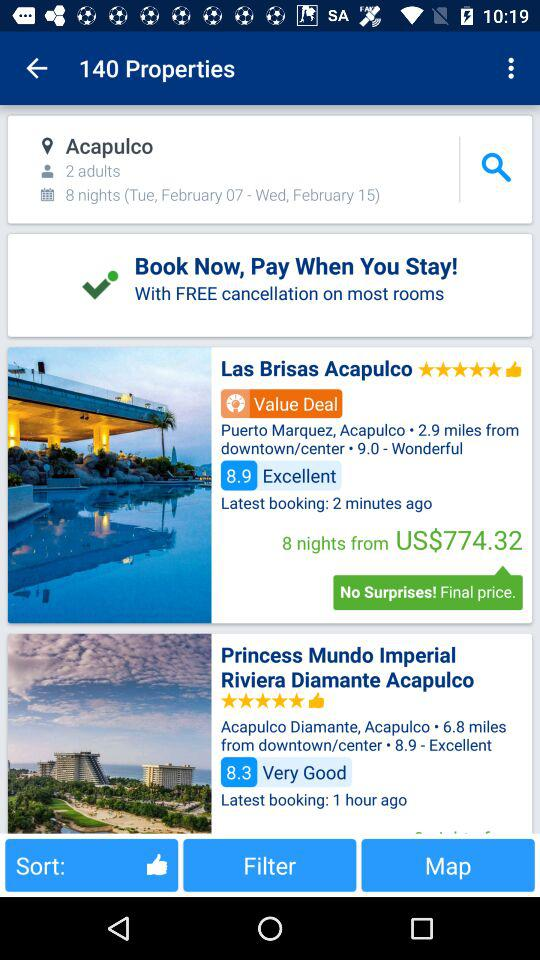How many people are there? There are 2 people. 